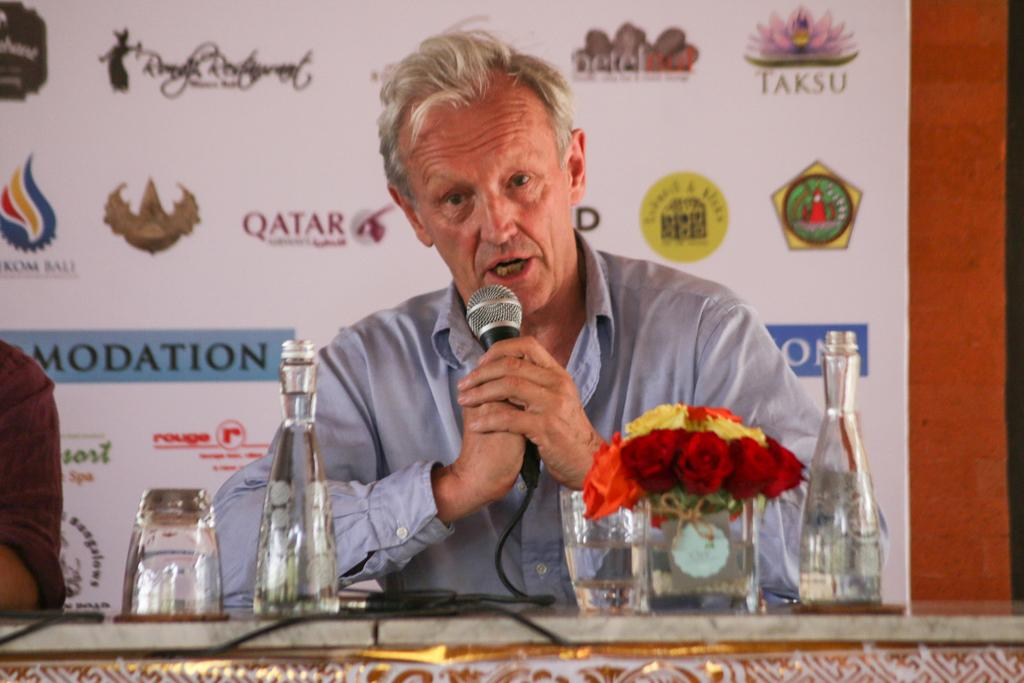<image>
Describe the image concisely. A man speaking in front of a sponsor poster with organizations such as Taksu and Kom Bali on it. 